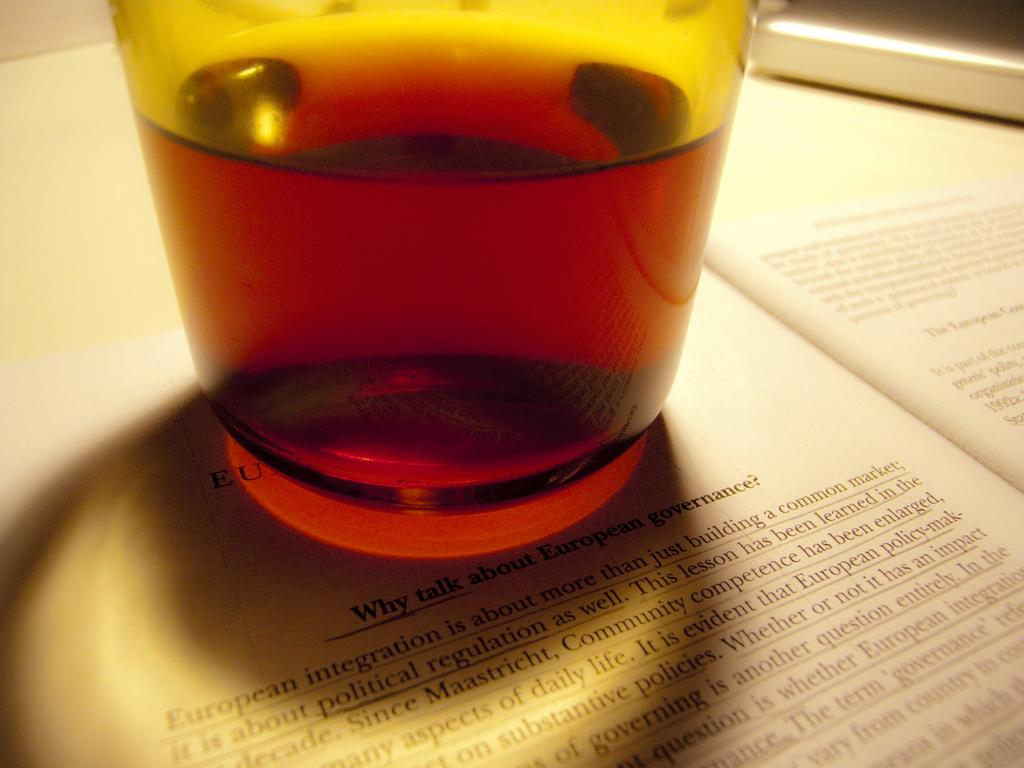What is inside the glass that is visible in the image? There is a drink inside the glass in the image. What is the glass placed on? The glass is placed on a book. What type of neck accessory is visible in the image? There is no neck accessory present in the image. 